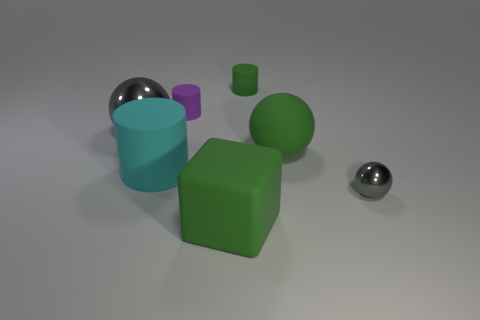What material is the large gray sphere?
Make the answer very short. Metal. There is a metal sphere on the left side of the tiny purple matte cylinder; does it have the same color as the tiny object right of the green rubber cylinder?
Your answer should be very brief. Yes. Is the shape of the tiny purple object the same as the gray object that is right of the big block?
Your answer should be very brief. No. What number of things are either big gray metal cubes or small things to the left of the tiny green rubber object?
Offer a very short reply. 1. What is the size of the sphere that is made of the same material as the large cyan object?
Keep it short and to the point. Large. What is the shape of the gray shiny object left of the metal object right of the small purple thing?
Your response must be concise. Sphere. How big is the object that is both right of the green rubber cylinder and behind the cyan object?
Make the answer very short. Large. Is there another tiny rubber object that has the same shape as the tiny gray thing?
Your answer should be very brief. No. The green thing in front of the gray metallic sphere right of the metal ball behind the tiny gray object is made of what material?
Ensure brevity in your answer.  Rubber. Are there any gray spheres of the same size as the purple matte cylinder?
Your answer should be compact. Yes. 